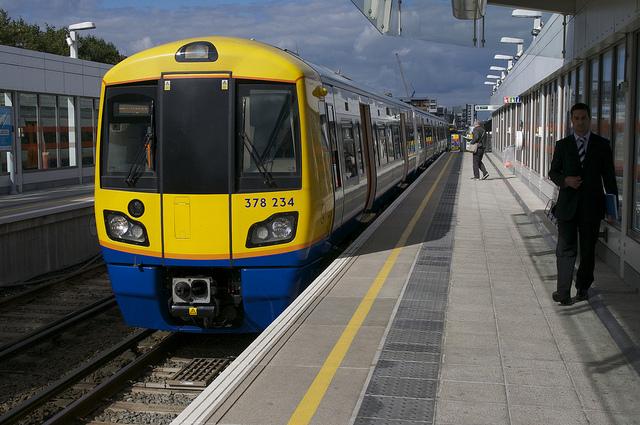What are the numbers on the train?
Concise answer only. 378 234. Where is the train?
Keep it brief. Station. Is anyone boarding the train?
Short answer required. No. What is the train designed to carry?
Be succinct. People. What is the 6 numbers on the train?
Give a very brief answer. 378 234. 